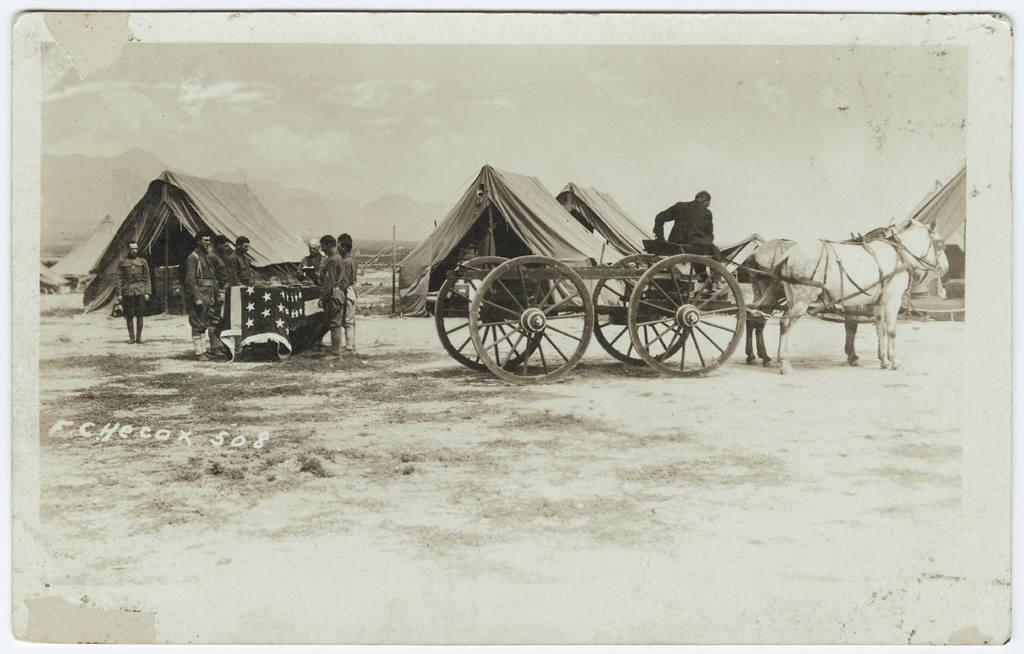What is the color scheme of the image? The image is black and white. Where are the people located in the image? The people are standing on the left side of the image. What can be seen on the right side of the image? There is a horse cart on the right side of the image. What is in the middle of the image? There are tents in the middle of the image. What type of animals can be seen at the zoo in the image? There is no zoo present in the image, and therefore no animals can be observed. What day of the week is it in the image? The day of the week is not mentioned or depicted in the image. 